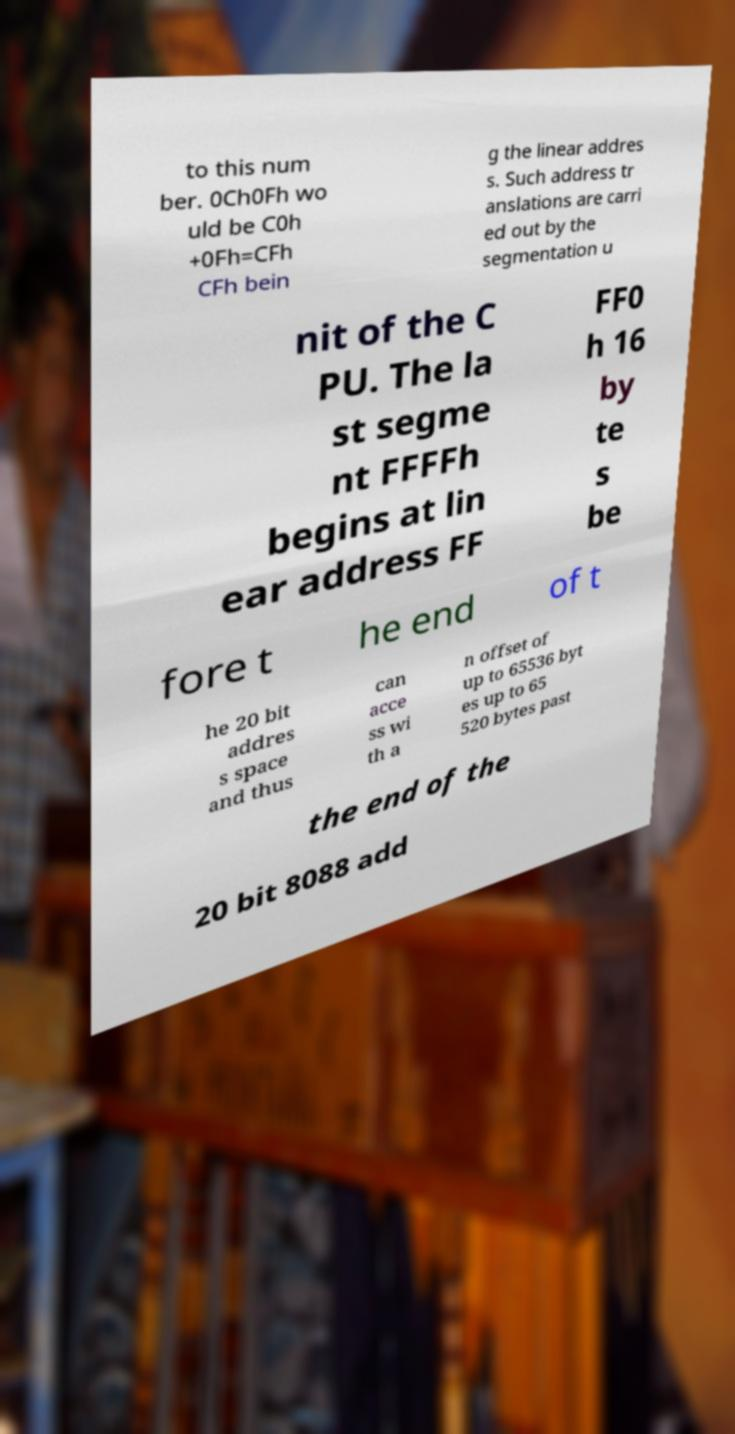Could you assist in decoding the text presented in this image and type it out clearly? to this num ber. 0Ch0Fh wo uld be C0h +0Fh=CFh CFh bein g the linear addres s. Such address tr anslations are carri ed out by the segmentation u nit of the C PU. The la st segme nt FFFFh begins at lin ear address FF FF0 h 16 by te s be fore t he end of t he 20 bit addres s space and thus can acce ss wi th a n offset of up to 65536 byt es up to 65 520 bytes past the end of the 20 bit 8088 add 